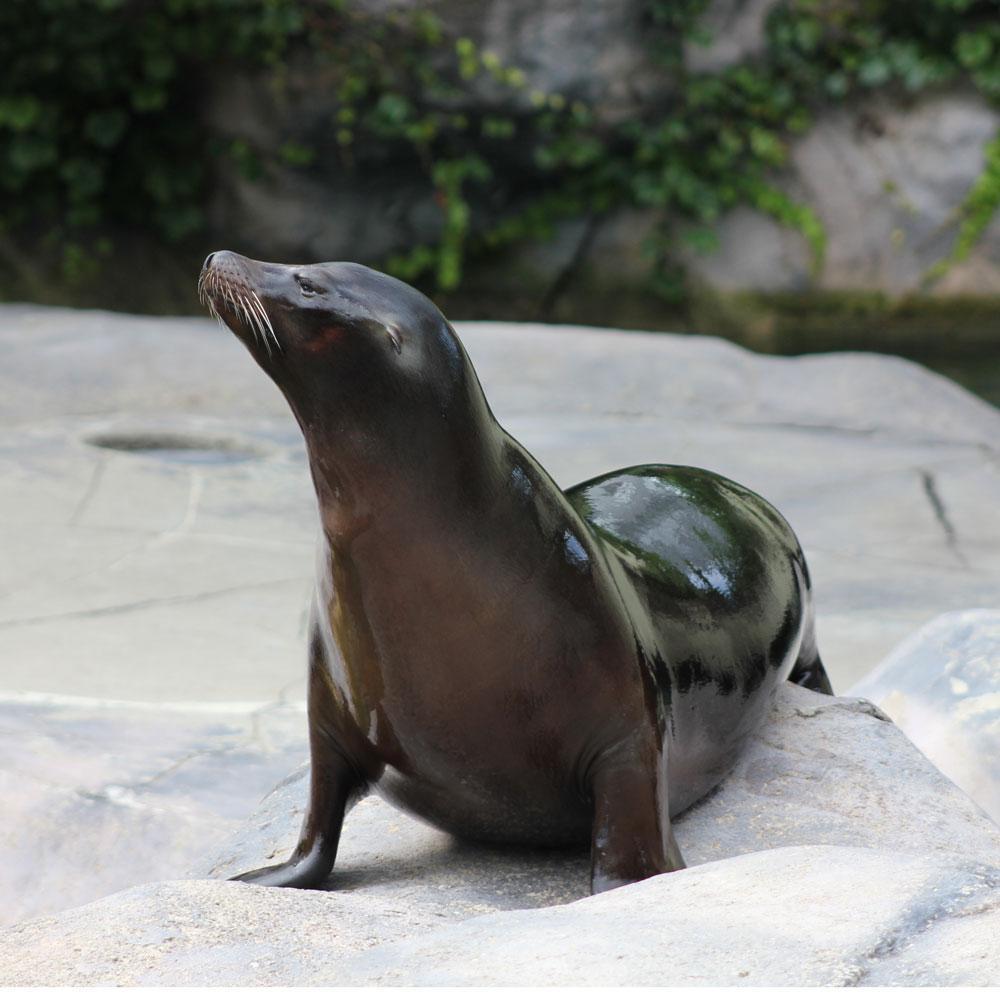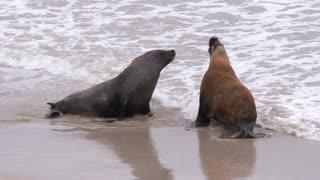The first image is the image on the left, the second image is the image on the right. For the images displayed, is the sentence "One image contains a single seal with head and shoulders upright, and the other image contains exactly two seals in the same scene together." factually correct? Answer yes or no. Yes. The first image is the image on the left, the second image is the image on the right. Evaluate the accuracy of this statement regarding the images: "There are exactly three sea lions in total.". Is it true? Answer yes or no. Yes. 